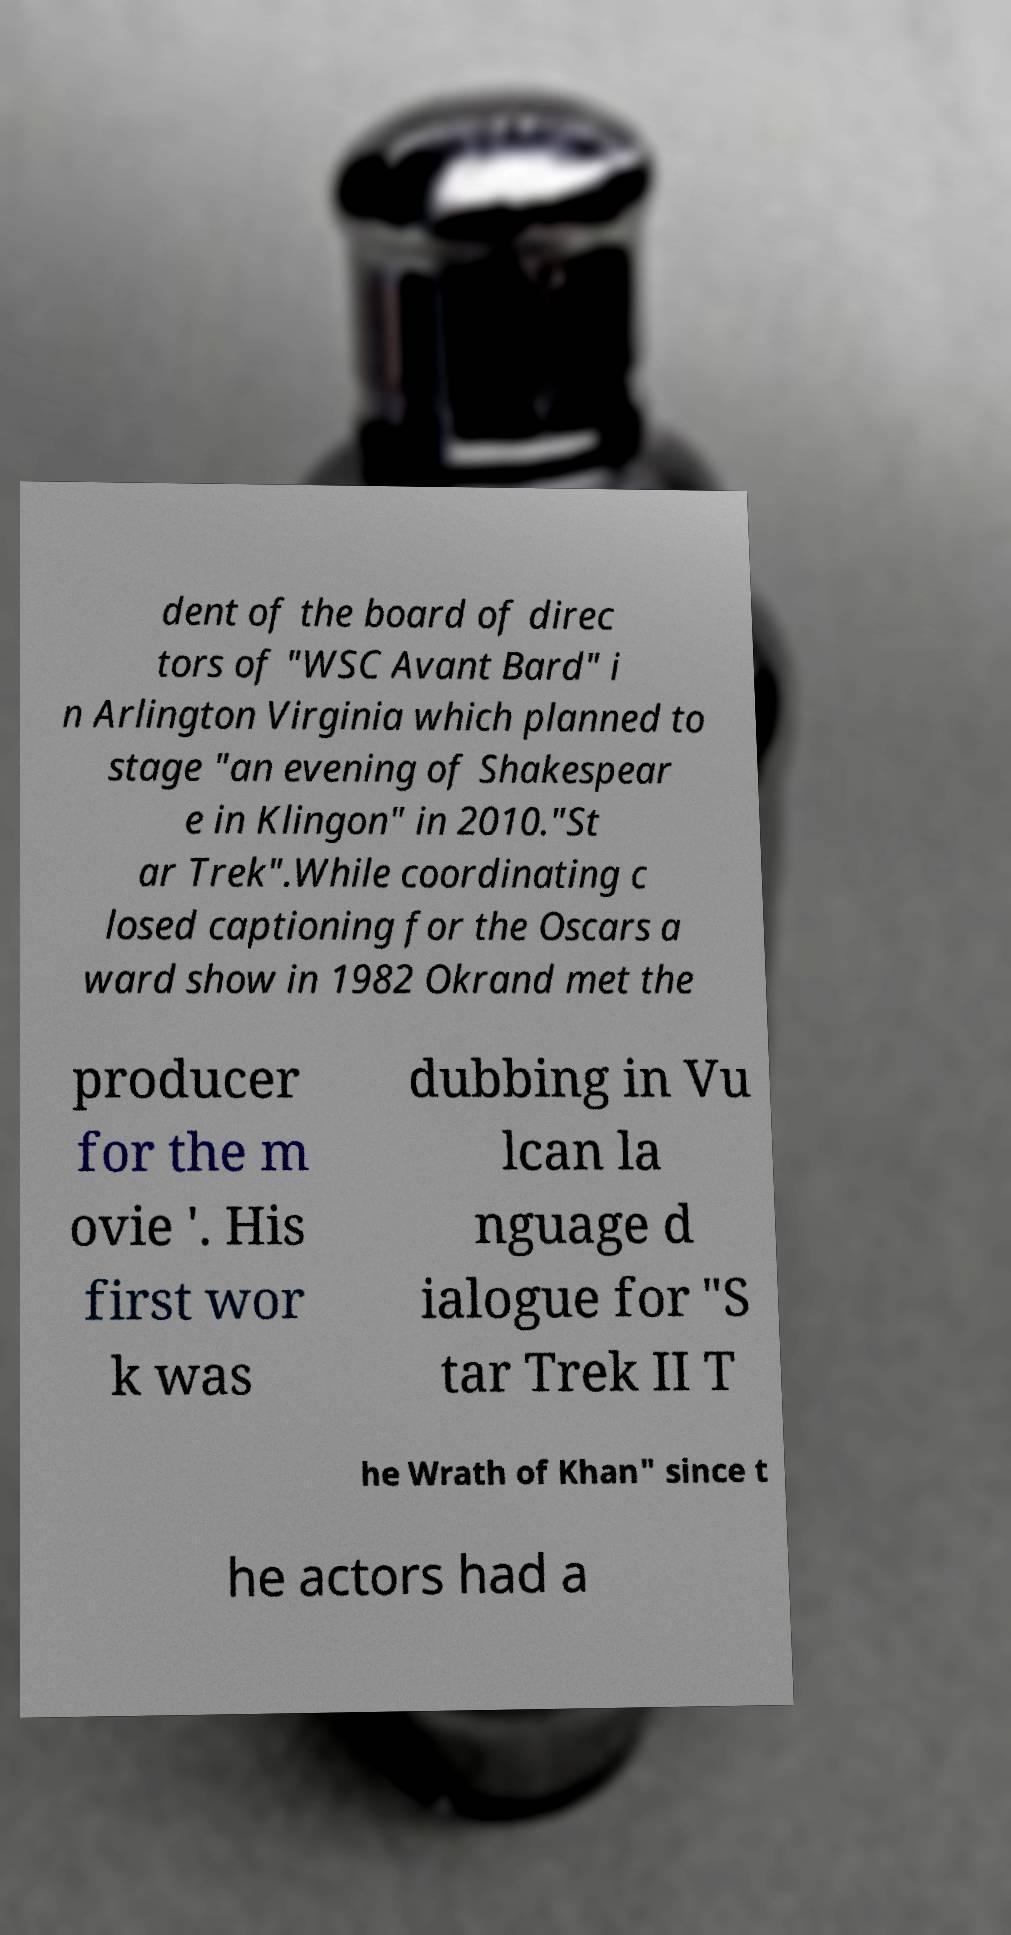Please identify and transcribe the text found in this image. dent of the board of direc tors of "WSC Avant Bard" i n Arlington Virginia which planned to stage "an evening of Shakespear e in Klingon" in 2010."St ar Trek".While coordinating c losed captioning for the Oscars a ward show in 1982 Okrand met the producer for the m ovie '. His first wor k was dubbing in Vu lcan la nguage d ialogue for "S tar Trek II T he Wrath of Khan" since t he actors had a 